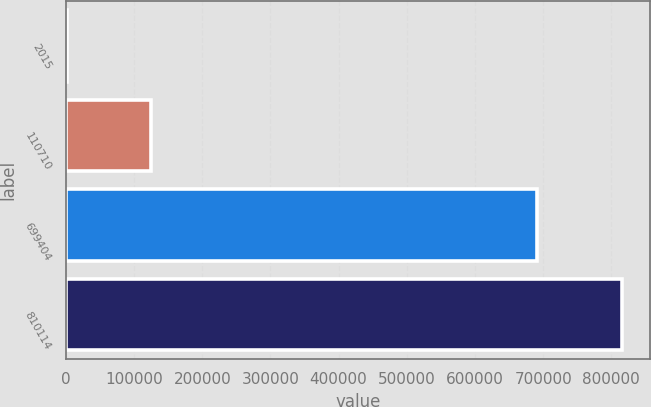Convert chart. <chart><loc_0><loc_0><loc_500><loc_500><bar_chart><fcel>2015<fcel>110710<fcel>699404<fcel>810114<nl><fcel>2013<fcel>124737<fcel>690586<fcel>815323<nl></chart> 